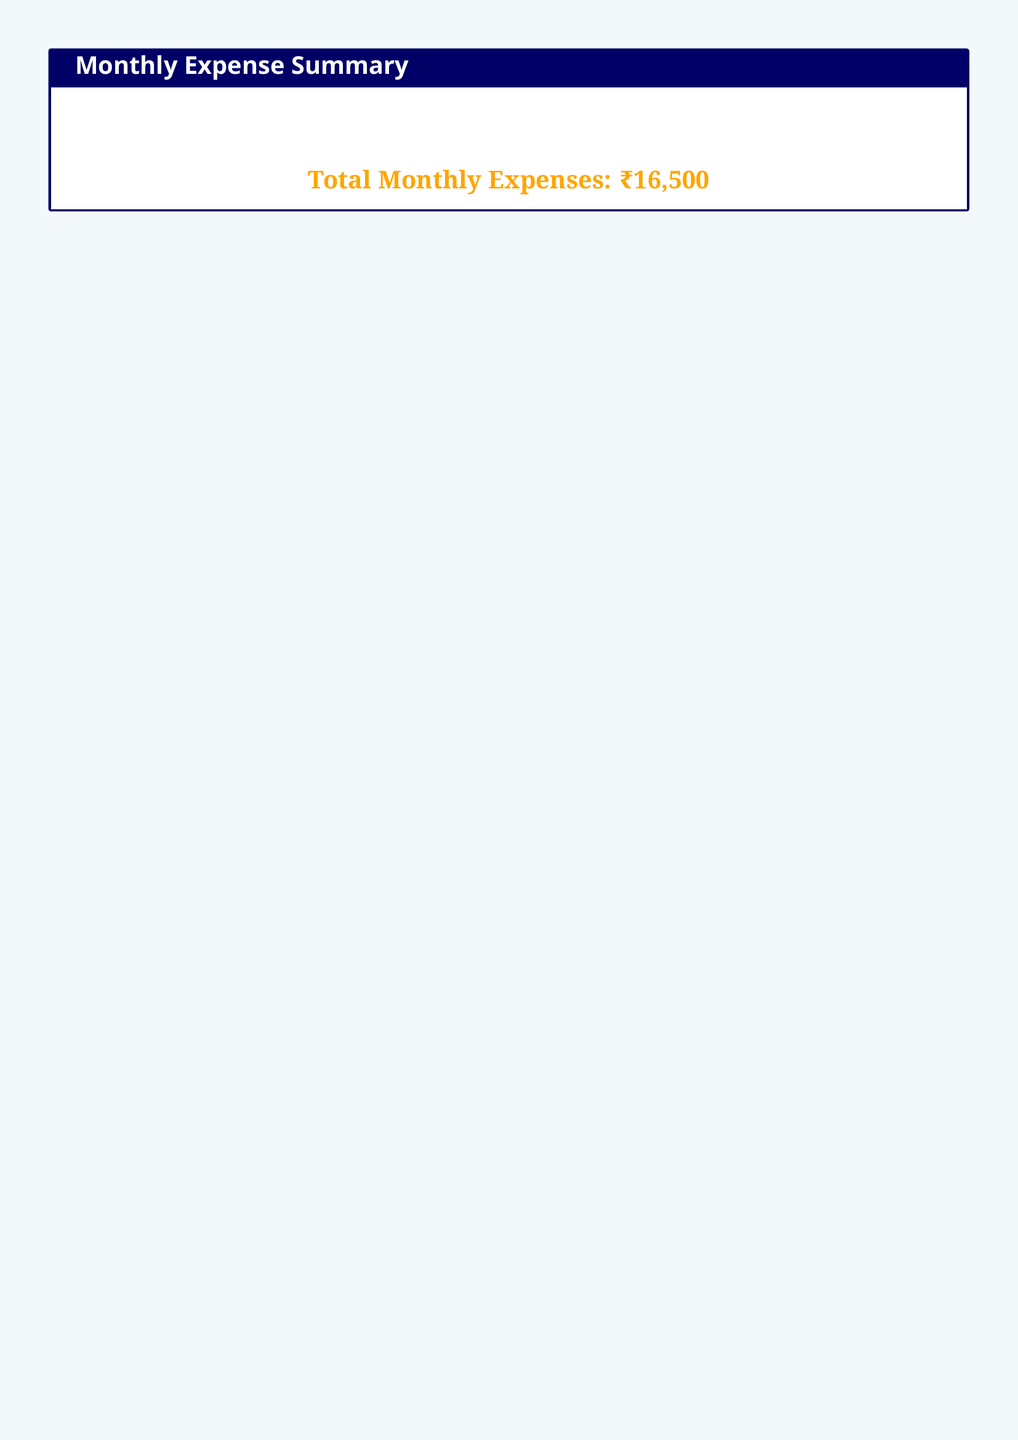What is the monthly rent amount? The monthly rent amount is specified in the Rent section of the document.
Answer: ₹8,000 Who is the landlord? The landlord's name is mentioned in the Rent section.
Answer: Mr. Singh What is the frequency of food expenses? The frequency of food expenses is mentioned in the Food section.
Answer: Monthly How much is spent on leisure activities? The total spent on leisure activities is stated in the Leisure Activities section.
Answer: ₹3,000 What is the total monthly expense? The total monthly expense is calculated and stated at the bottom of the document.
Answer: ₹16,500 How often is the gym membership renewed? The renewal frequency of the gym membership is mentioned in the Leisure Activities section.
Answer: Monthly What type of vehicle is used for occasional trips? The type of vehicle used for occasional trips is specified in the Transportation section.
Answer: Auto Rickshaw How much is spent on online streaming services? The amount spent on online streaming services is detailed in the Leisure Activities section.
Answer: ₹500 